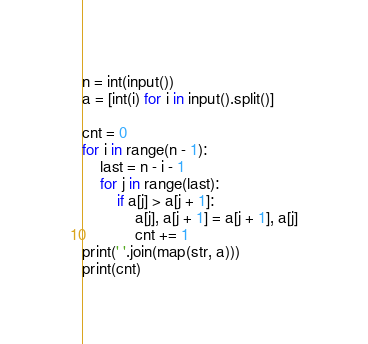Convert code to text. <code><loc_0><loc_0><loc_500><loc_500><_Python_>n = int(input())
a = [int(i) for i in input().split()]

cnt = 0
for i in range(n - 1):
    last = n - i - 1
    for j in range(last):
        if a[j] > a[j + 1]:
            a[j], a[j + 1] = a[j + 1], a[j]
            cnt += 1
print(' '.join(map(str, a)))
print(cnt)


</code> 